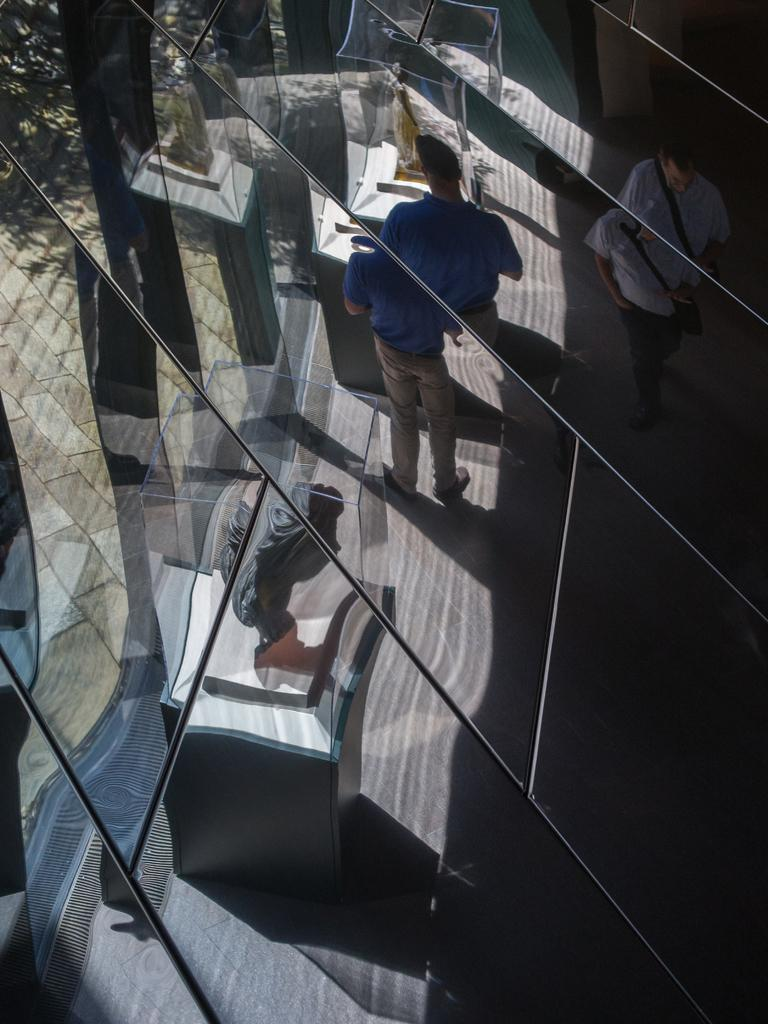What is the main feature of the wall in the image? The wall has pieces of glass in the image. What can be seen through the glass? Persons and other unspecified objects are visible through the glass. What is located on a pedestal in the image? There is a statue on a pedestal in the image. What type of beef is being served on the pedestal next to the statue in the image? There is no beef present in the image; it features a wall with glass, persons visible through the glass, and a statue on a pedestal. 